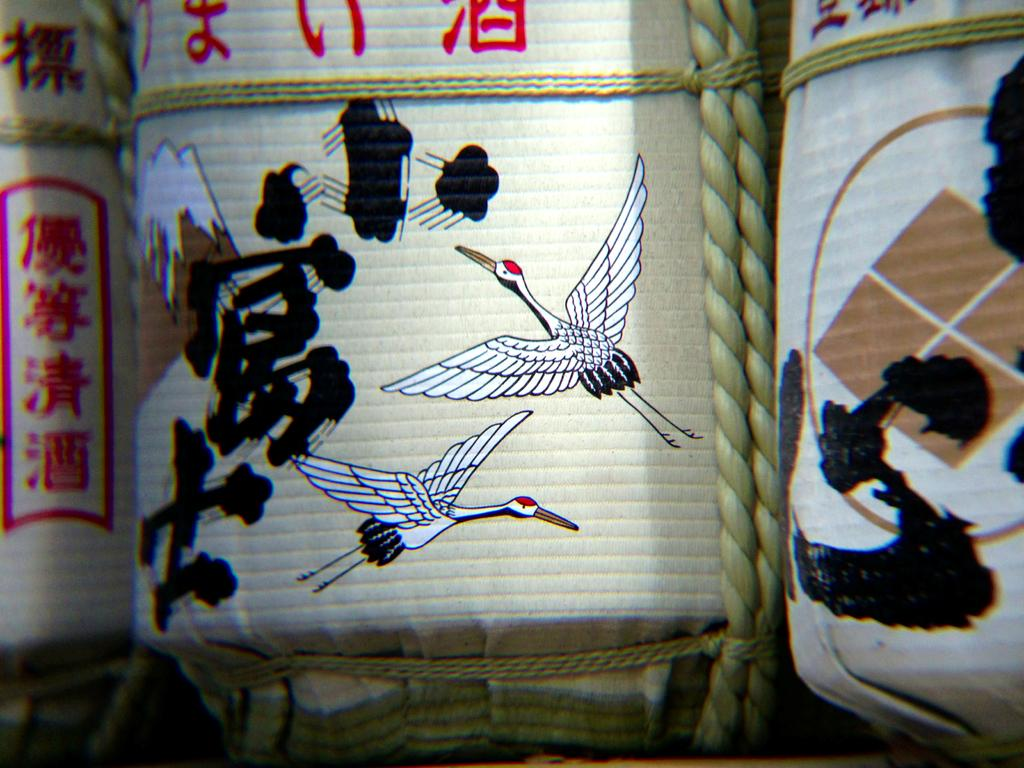What is depicted on the blocks in the image? There are paintings on blocks in the image. What type of alley can be seen in the background of the image? There is no alley present in the image; it only features paintings on blocks. 